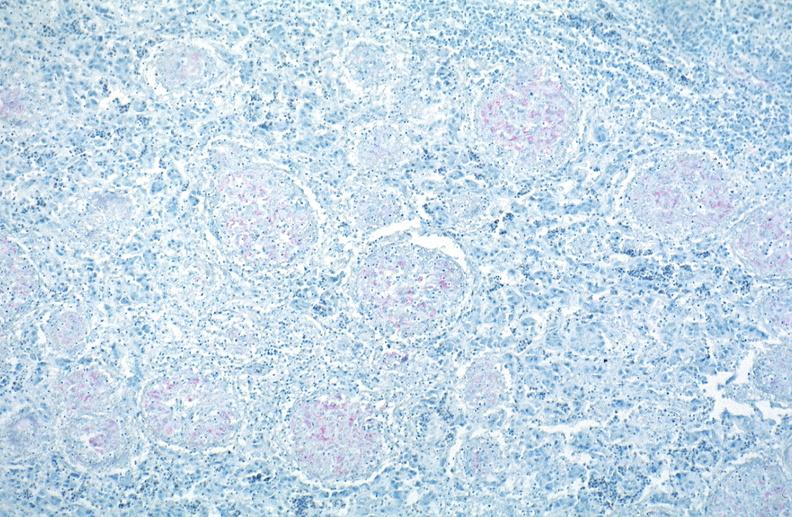s respiratory present?
Answer the question using a single word or phrase. Yes 